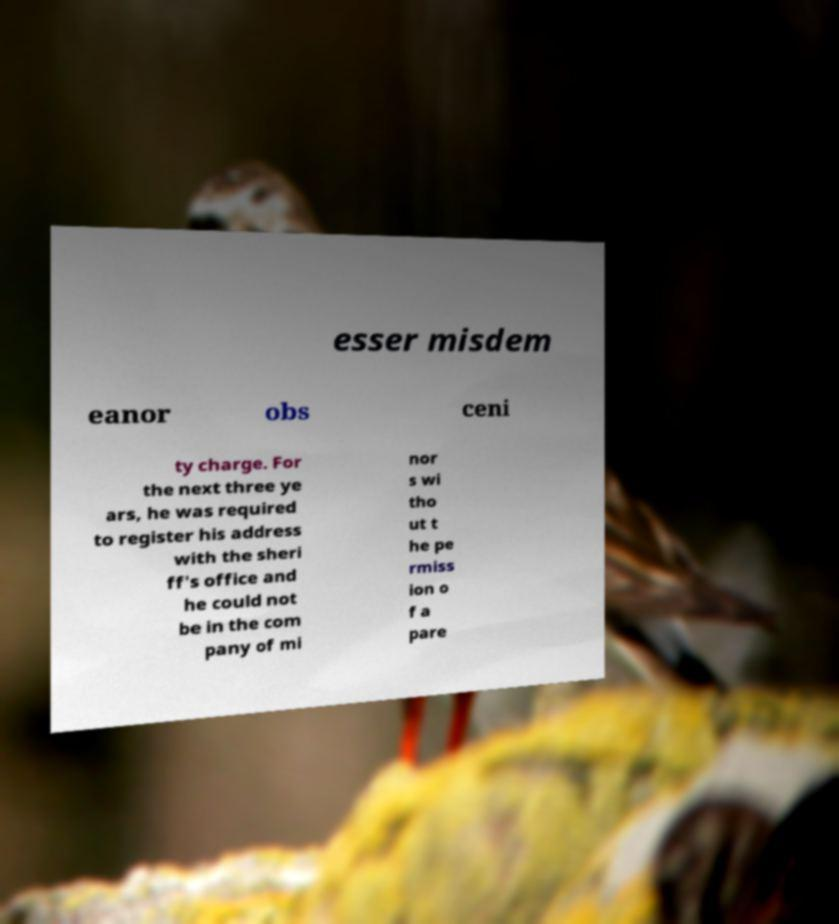Can you read and provide the text displayed in the image?This photo seems to have some interesting text. Can you extract and type it out for me? esser misdem eanor obs ceni ty charge. For the next three ye ars, he was required to register his address with the sheri ff's office and he could not be in the com pany of mi nor s wi tho ut t he pe rmiss ion o f a pare 